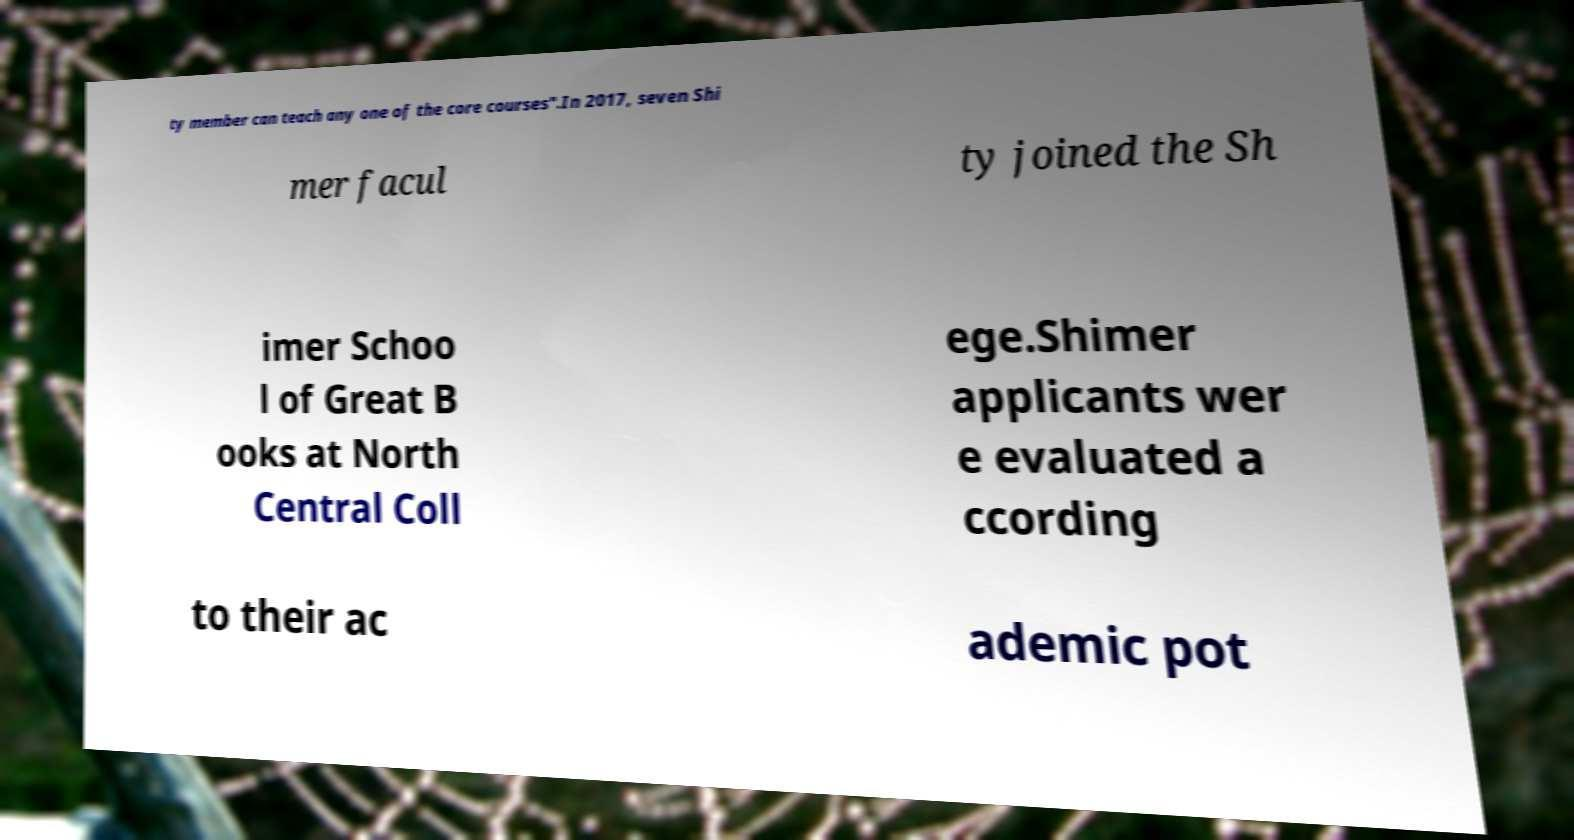What messages or text are displayed in this image? I need them in a readable, typed format. ty member can teach any one of the core courses".In 2017, seven Shi mer facul ty joined the Sh imer Schoo l of Great B ooks at North Central Coll ege.Shimer applicants wer e evaluated a ccording to their ac ademic pot 